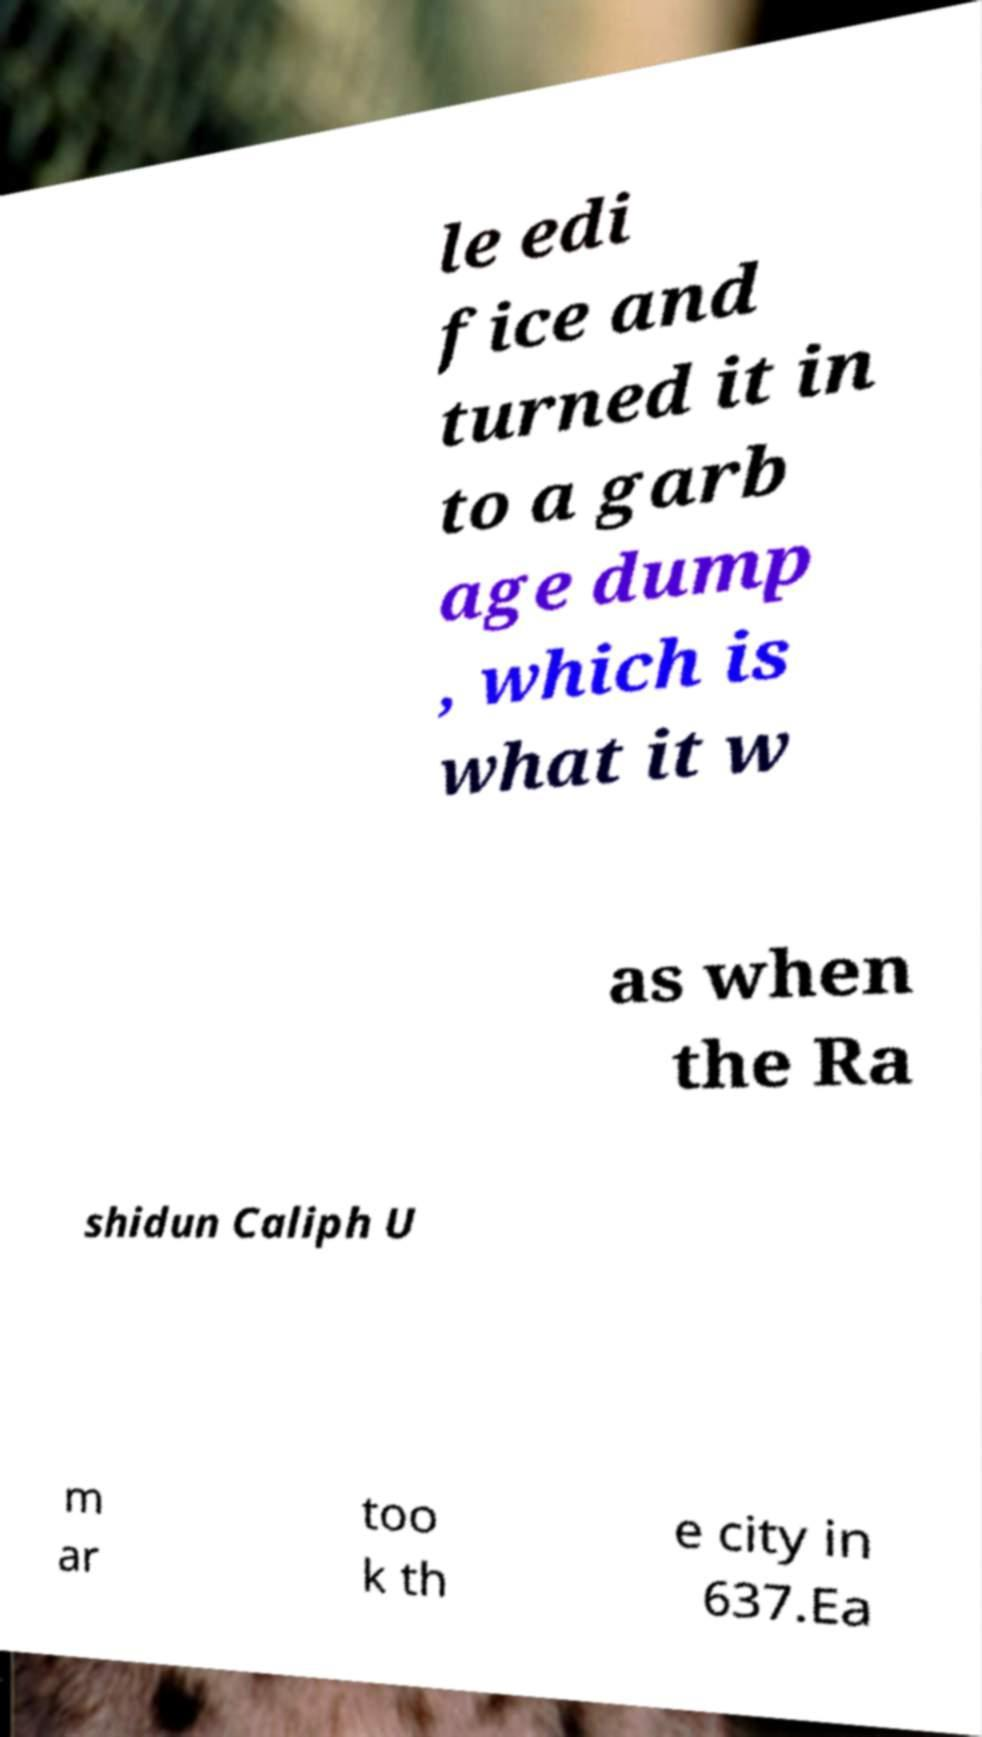Could you assist in decoding the text presented in this image and type it out clearly? le edi fice and turned it in to a garb age dump , which is what it w as when the Ra shidun Caliph U m ar too k th e city in 637.Ea 